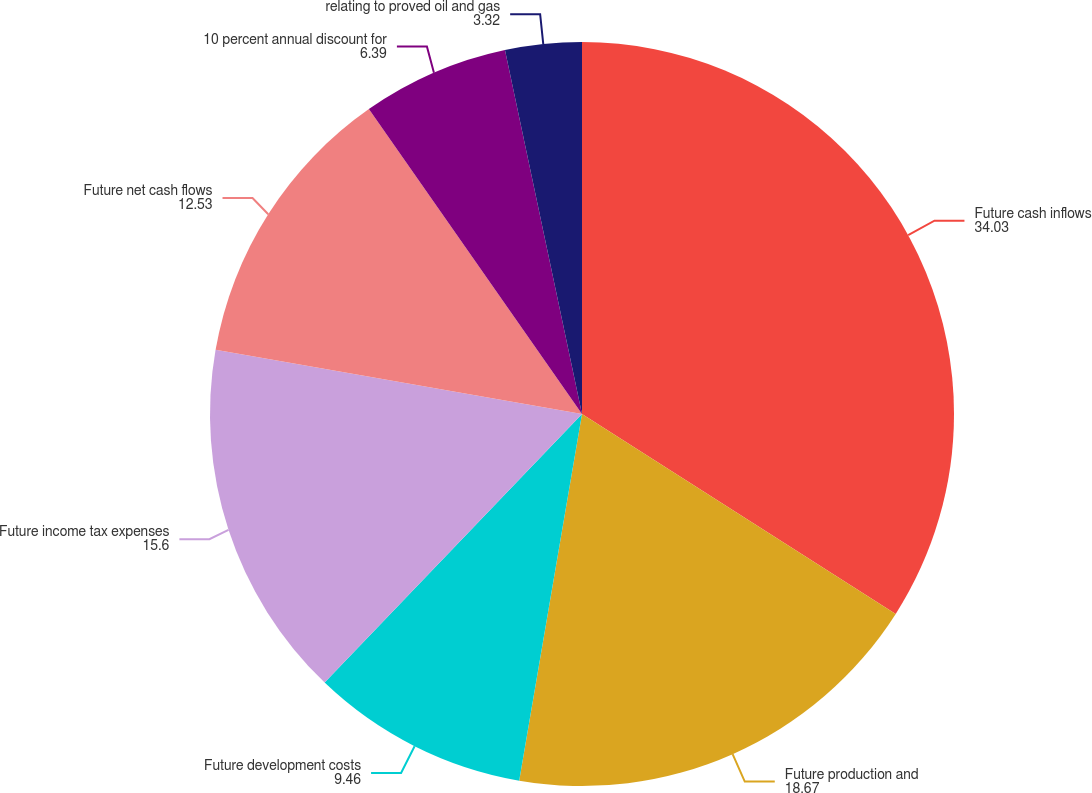Convert chart to OTSL. <chart><loc_0><loc_0><loc_500><loc_500><pie_chart><fcel>Future cash inflows<fcel>Future production and<fcel>Future development costs<fcel>Future income tax expenses<fcel>Future net cash flows<fcel>10 percent annual discount for<fcel>relating to proved oil and gas<nl><fcel>34.03%<fcel>18.67%<fcel>9.46%<fcel>15.6%<fcel>12.53%<fcel>6.39%<fcel>3.32%<nl></chart> 